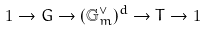Convert formula to latex. <formula><loc_0><loc_0><loc_500><loc_500>1 \rightarrow G \rightarrow ( \mathbb { G } _ { m } ^ { \vee } ) ^ { d } \rightarrow T \rightarrow 1</formula> 